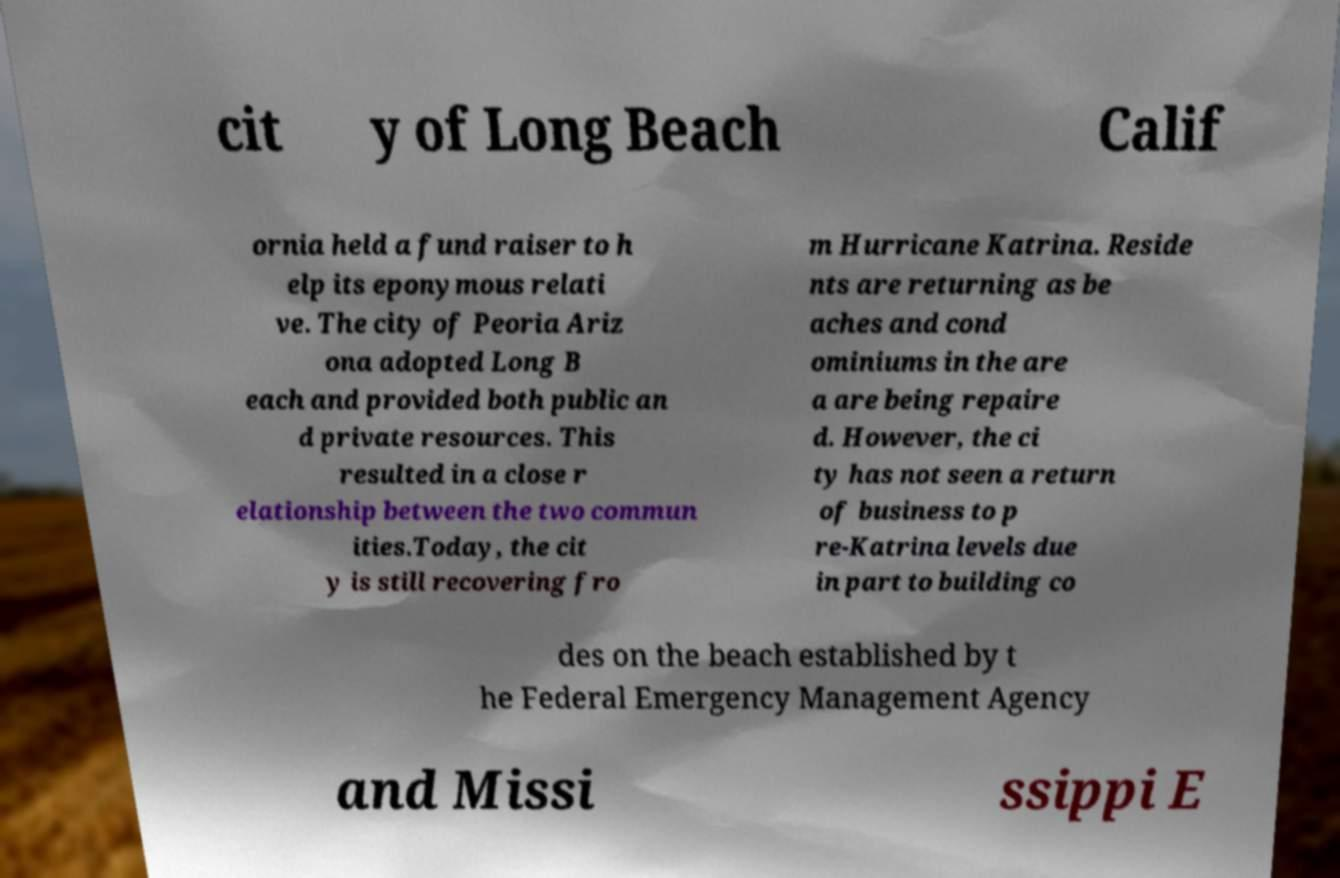Could you assist in decoding the text presented in this image and type it out clearly? cit y of Long Beach Calif ornia held a fund raiser to h elp its eponymous relati ve. The city of Peoria Ariz ona adopted Long B each and provided both public an d private resources. This resulted in a close r elationship between the two commun ities.Today, the cit y is still recovering fro m Hurricane Katrina. Reside nts are returning as be aches and cond ominiums in the are a are being repaire d. However, the ci ty has not seen a return of business to p re-Katrina levels due in part to building co des on the beach established by t he Federal Emergency Management Agency and Missi ssippi E 